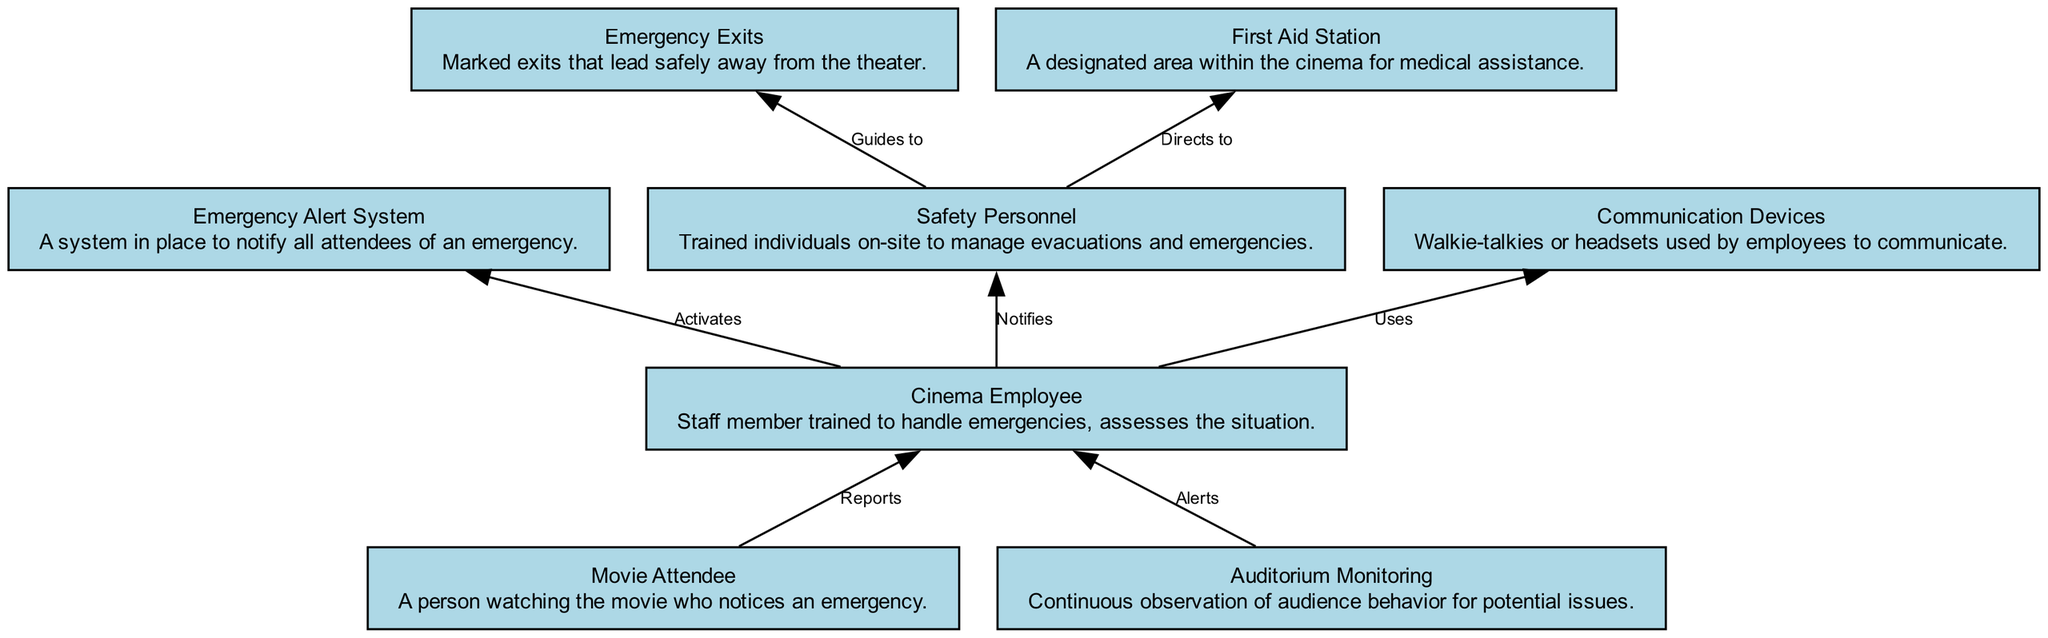What is the first step an attendee takes in case of an emergency? The first step is that the Movie Attendee reports the situation to the Cinema Employee. This is reflected in the diagram where the edge indicates the reporting action from the Movie Attendee to the Cinema Employee.
Answer: Reports Who does the Cinema Employee notify? The Cinema Employee notifies Safety Personnel. This is evident from the edge that shows the notification relationship from the Cinema Employee to Safety Personnel in the diagram.
Answer: Safety Personnel How many total nodes are there in the diagram? There are eight nodes in the diagram representing different elements involved in the emergency protocol. This can be determined by counting all the distinct elements listed in the diagram.
Answer: Eight What does the Safety Personnel direct the Cinema Employee to do? The Safety Personnel directs the Cinema Employee to the First Aid Station. This is indicated by the edge between the Safety Personnel and First Aid Station in the diagram, showing the direction of communication.
Answer: Directs to Which system is activated by the Cinema Employee after being informed of an emergency? The Cinema Employee activates the Emergency Alert System following the reporting of the emergency. This action is clearly represented by the edge leading from the Cinema Employee to the Emergency Alert System in the diagram.
Answer: Activates Where does the Safety Personnel guide attendees during an emergency? Safety Personnel guides attendees to the Emergency Exits for safe evacuation. This guidance is shown in the diagram by the connection from Safety Personnel to Emergency Exits.
Answer: Guides to What is the role of the Auditorium Monitoring element? The role of Auditorium Monitoring is to alert the Cinema Employee of any potential issues, as indicated by the directed edge showing this communication flow in the diagram.
Answer: Alerts What communication devices do Cinema Employees use during the emergency protocol? The Cinema Employees use Communication Devices, which is highlighted in the diagram by the edge pointing from Cinema Employee to Communication Devices, indicating that they are utilized for communication.
Answer: Uses 